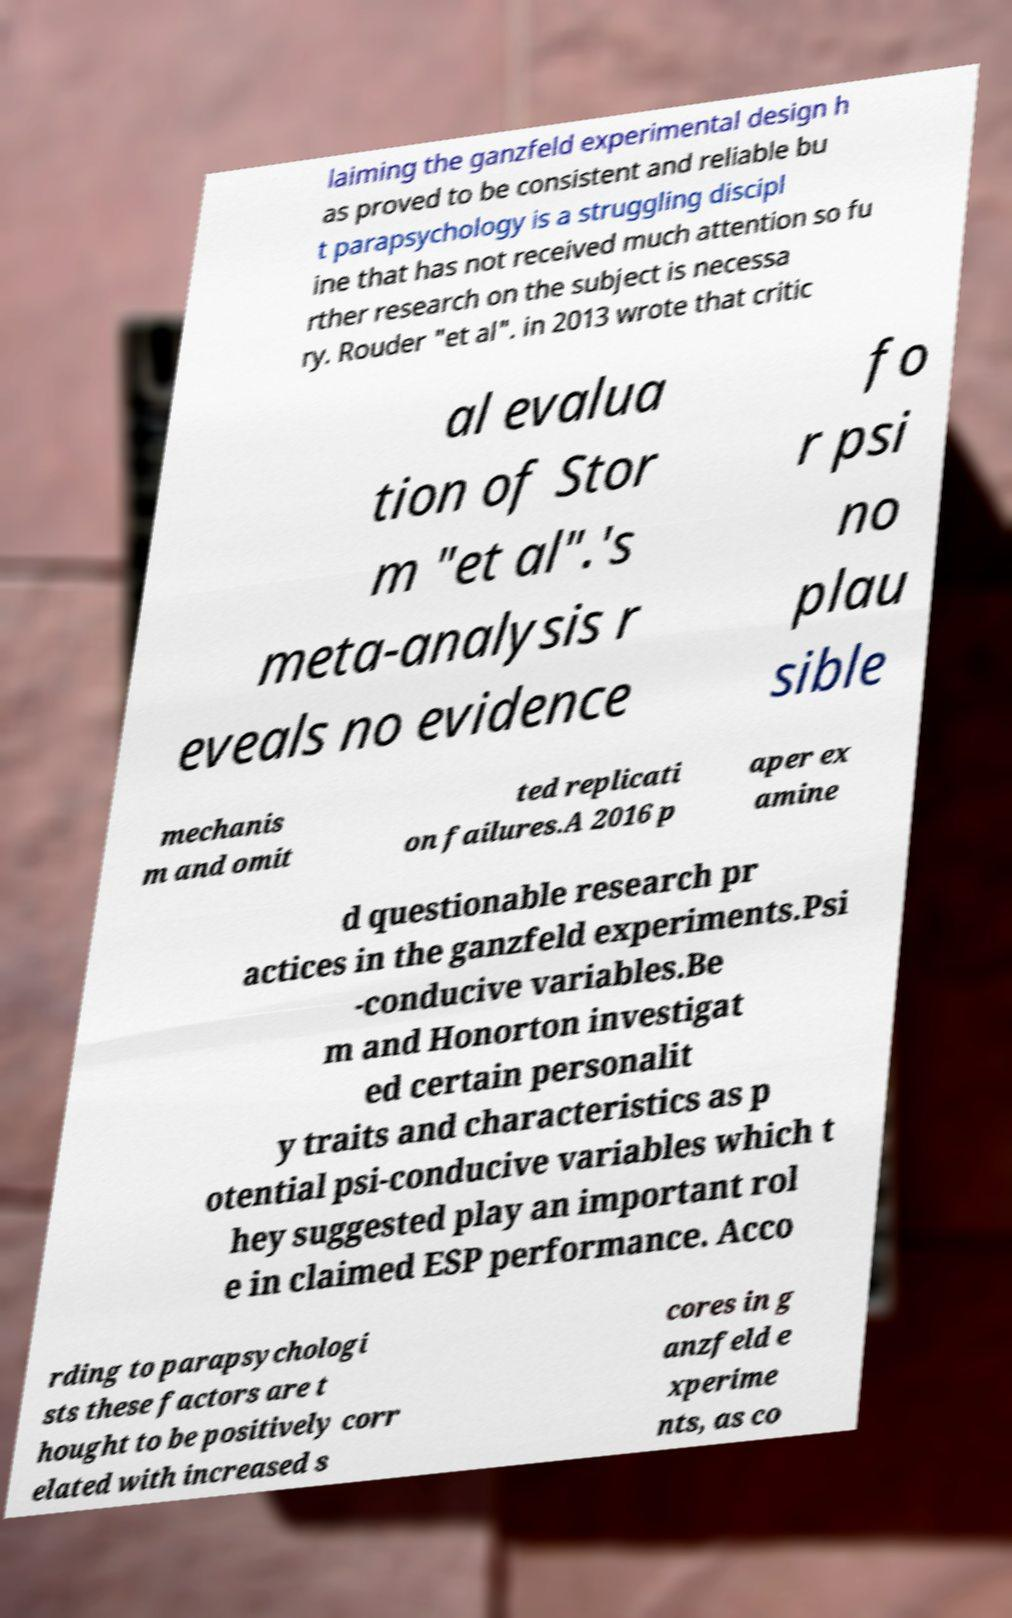Can you read and provide the text displayed in the image?This photo seems to have some interesting text. Can you extract and type it out for me? laiming the ganzfeld experimental design h as proved to be consistent and reliable bu t parapsychology is a struggling discipl ine that has not received much attention so fu rther research on the subject is necessa ry. Rouder "et al". in 2013 wrote that critic al evalua tion of Stor m "et al".'s meta-analysis r eveals no evidence fo r psi no plau sible mechanis m and omit ted replicati on failures.A 2016 p aper ex amine d questionable research pr actices in the ganzfeld experiments.Psi -conducive variables.Be m and Honorton investigat ed certain personalit y traits and characteristics as p otential psi-conducive variables which t hey suggested play an important rol e in claimed ESP performance. Acco rding to parapsychologi sts these factors are t hought to be positively corr elated with increased s cores in g anzfeld e xperime nts, as co 